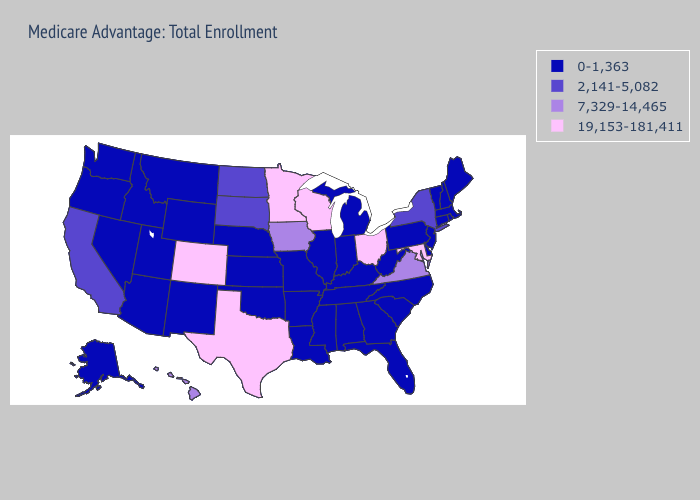Among the states that border Arkansas , which have the highest value?
Give a very brief answer. Texas. Name the states that have a value in the range 7,329-14,465?
Keep it brief. Hawaii, Iowa, Virginia. Name the states that have a value in the range 19,153-181,411?
Short answer required. Colorado, Maryland, Minnesota, Ohio, Texas, Wisconsin. What is the value of Missouri?
Concise answer only. 0-1,363. Does the map have missing data?
Concise answer only. No. Which states have the highest value in the USA?
Write a very short answer. Colorado, Maryland, Minnesota, Ohio, Texas, Wisconsin. What is the value of Utah?
Quick response, please. 0-1,363. Does Idaho have the highest value in the West?
Give a very brief answer. No. What is the value of Arkansas?
Give a very brief answer. 0-1,363. Among the states that border New Mexico , does Utah have the lowest value?
Short answer required. Yes. What is the highest value in the Northeast ?
Give a very brief answer. 2,141-5,082. Does the first symbol in the legend represent the smallest category?
Keep it brief. Yes. Name the states that have a value in the range 19,153-181,411?
Write a very short answer. Colorado, Maryland, Minnesota, Ohio, Texas, Wisconsin. Name the states that have a value in the range 0-1,363?
Short answer required. Alaska, Alabama, Arkansas, Arizona, Connecticut, Delaware, Florida, Georgia, Idaho, Illinois, Indiana, Kansas, Kentucky, Louisiana, Massachusetts, Maine, Michigan, Missouri, Mississippi, Montana, North Carolina, Nebraska, New Hampshire, New Jersey, New Mexico, Nevada, Oklahoma, Oregon, Pennsylvania, Rhode Island, South Carolina, Tennessee, Utah, Vermont, Washington, West Virginia, Wyoming. Does New Mexico have the highest value in the USA?
Quick response, please. No. 